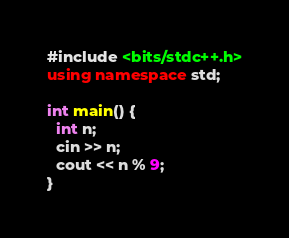<code> <loc_0><loc_0><loc_500><loc_500><_C++_>#include <bits/stdc++.h>
using namespace std;

int main() {
  int n;
  cin >> n;
  cout << n % 9;
}</code> 